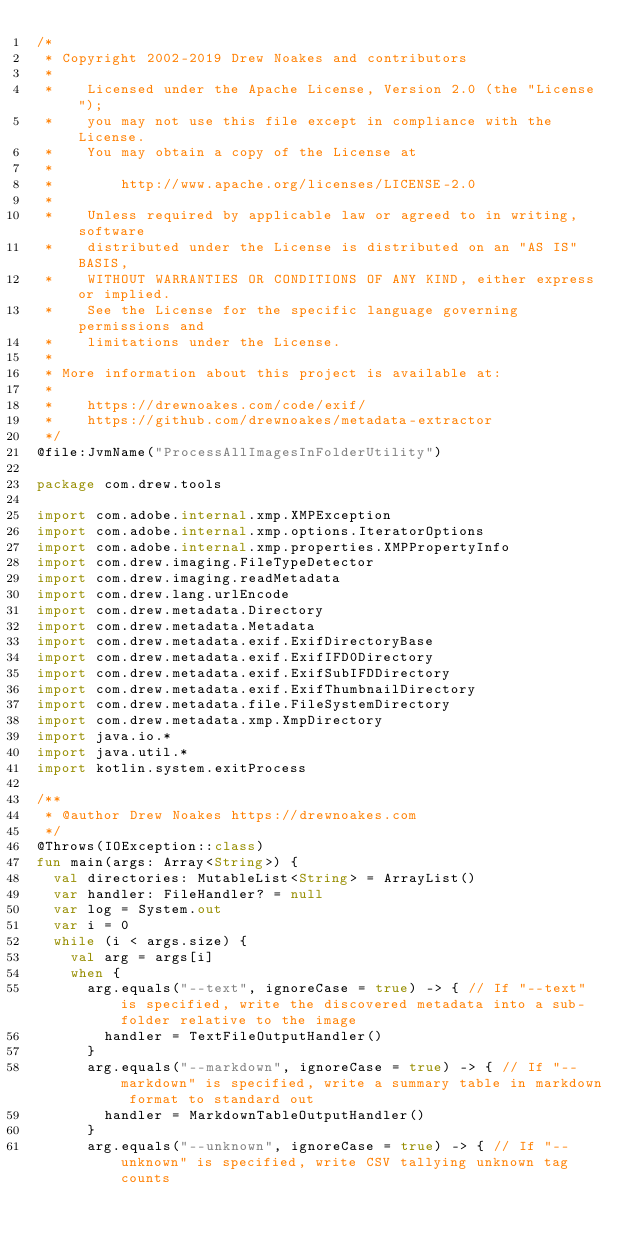<code> <loc_0><loc_0><loc_500><loc_500><_Kotlin_>/*
 * Copyright 2002-2019 Drew Noakes and contributors
 *
 *    Licensed under the Apache License, Version 2.0 (the "License");
 *    you may not use this file except in compliance with the License.
 *    You may obtain a copy of the License at
 *
 *        http://www.apache.org/licenses/LICENSE-2.0
 *
 *    Unless required by applicable law or agreed to in writing, software
 *    distributed under the License is distributed on an "AS IS" BASIS,
 *    WITHOUT WARRANTIES OR CONDITIONS OF ANY KIND, either express or implied.
 *    See the License for the specific language governing permissions and
 *    limitations under the License.
 *
 * More information about this project is available at:
 *
 *    https://drewnoakes.com/code/exif/
 *    https://github.com/drewnoakes/metadata-extractor
 */
@file:JvmName("ProcessAllImagesInFolderUtility")

package com.drew.tools

import com.adobe.internal.xmp.XMPException
import com.adobe.internal.xmp.options.IteratorOptions
import com.adobe.internal.xmp.properties.XMPPropertyInfo
import com.drew.imaging.FileTypeDetector
import com.drew.imaging.readMetadata
import com.drew.lang.urlEncode
import com.drew.metadata.Directory
import com.drew.metadata.Metadata
import com.drew.metadata.exif.ExifDirectoryBase
import com.drew.metadata.exif.ExifIFD0Directory
import com.drew.metadata.exif.ExifSubIFDDirectory
import com.drew.metadata.exif.ExifThumbnailDirectory
import com.drew.metadata.file.FileSystemDirectory
import com.drew.metadata.xmp.XmpDirectory
import java.io.*
import java.util.*
import kotlin.system.exitProcess

/**
 * @author Drew Noakes https://drewnoakes.com
 */
@Throws(IOException::class)
fun main(args: Array<String>) {
  val directories: MutableList<String> = ArrayList()
  var handler: FileHandler? = null
  var log = System.out
  var i = 0
  while (i < args.size) {
    val arg = args[i]
    when {
      arg.equals("--text", ignoreCase = true) -> { // If "--text" is specified, write the discovered metadata into a sub-folder relative to the image
        handler = TextFileOutputHandler()
      }
      arg.equals("--markdown", ignoreCase = true) -> { // If "--markdown" is specified, write a summary table in markdown format to standard out
        handler = MarkdownTableOutputHandler()
      }
      arg.equals("--unknown", ignoreCase = true) -> { // If "--unknown" is specified, write CSV tallying unknown tag counts</code> 